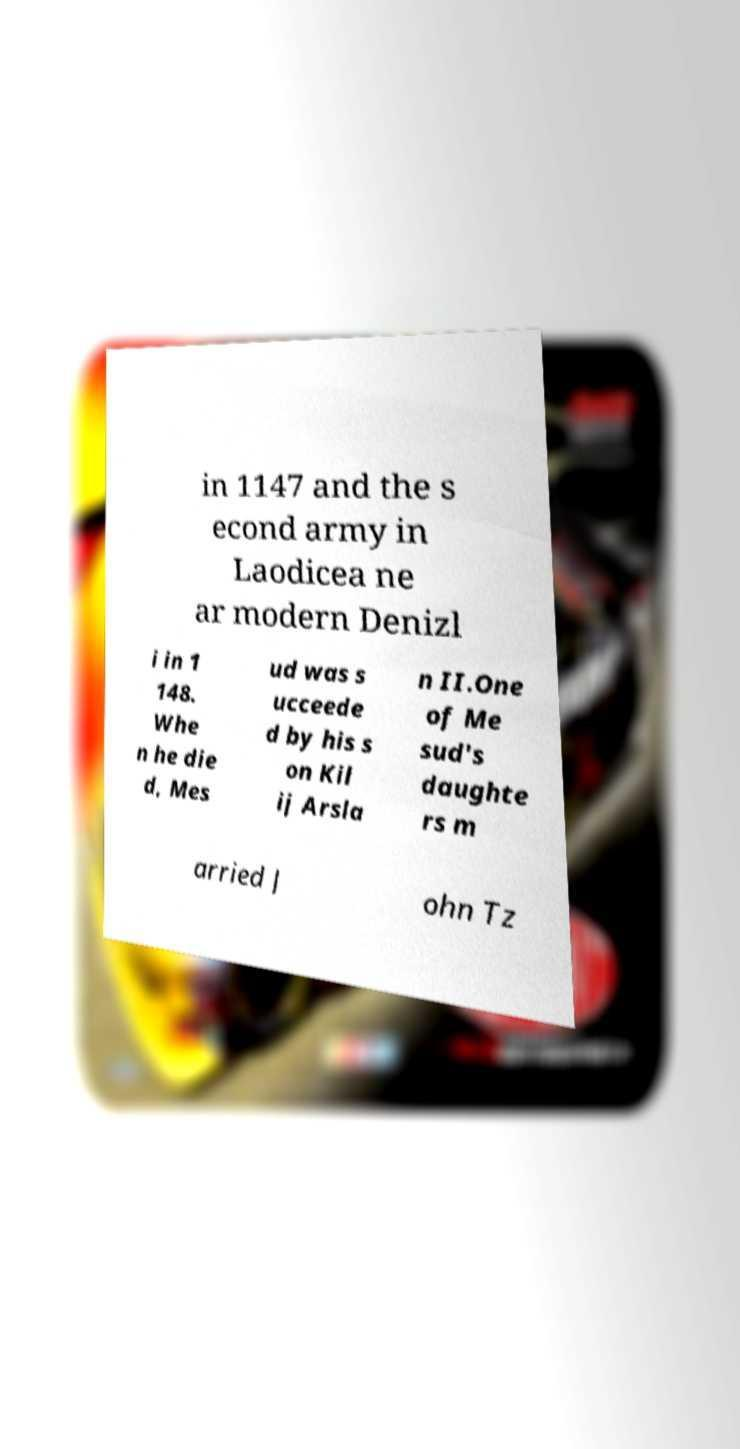Please read and relay the text visible in this image. What does it say? in 1147 and the s econd army in Laodicea ne ar modern Denizl i in 1 148. Whe n he die d, Mes ud was s ucceede d by his s on Kil ij Arsla n II.One of Me sud's daughte rs m arried J ohn Tz 